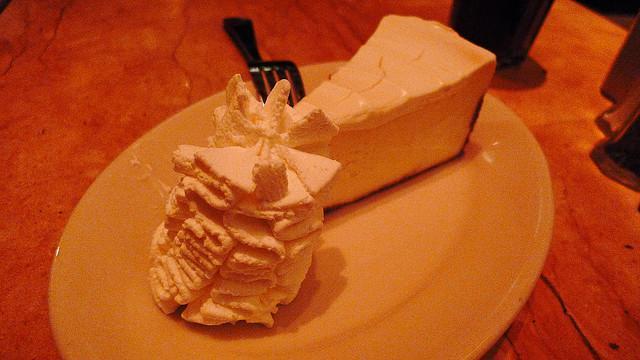How many kinds of food?
Give a very brief answer. 2. How many cakes can you see?
Give a very brief answer. 2. How many forks can you see?
Give a very brief answer. 1. 